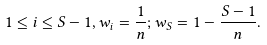Convert formula to latex. <formula><loc_0><loc_0><loc_500><loc_500>1 \leq i \leq S - 1 , w _ { i } = \frac { 1 } { n } ; w _ { S } = 1 - \frac { S - 1 } { n } .</formula> 